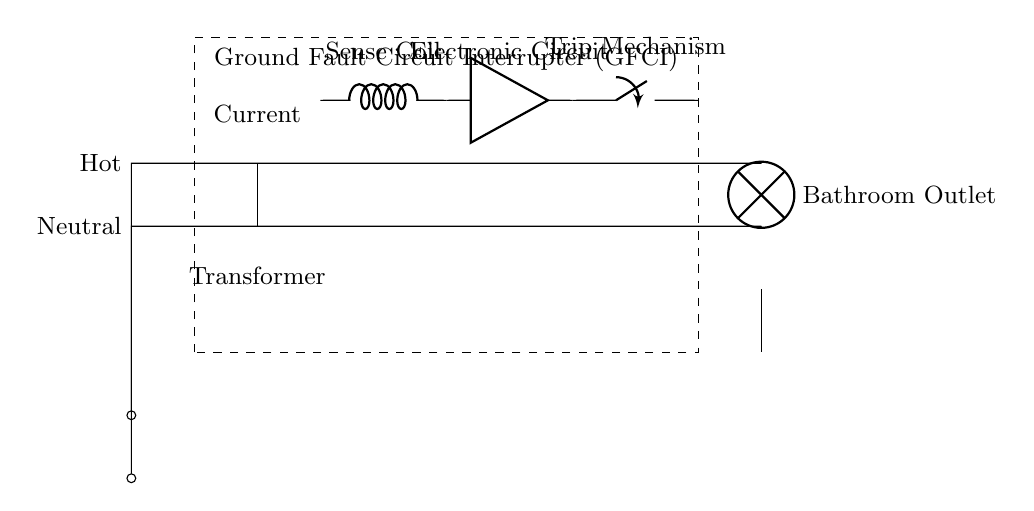What is the main function of the GFCI? The main function of the GFCI is to detect ground faults and prevent electric shock by interrupting the circuit.
Answer: Detect ground faults What type of load is connected to the circuit? The load connected to the circuit is a lamp, indicated by the symbol in the diagram.
Answer: Lamp How many components are inside the GFCI? The GFCI contains four main components: a current transformer, a sense coil, an electronic circuit, and a trip mechanism.
Answer: Four What is the purpose of the sense coil? The purpose of the sense coil is to detect the current imbalance caused by a ground fault, which helps in tripping the circuit.
Answer: Detect current imbalance What happens when a ground fault is detected? When a ground fault is detected, the trip mechanism activates to open the circuit, stopping the flow of electricity to prevent shock.
Answer: Circuit opens What do the labels "Hot" and "Neutral" indicate? The labels identify the two main power lines in the circuit: "Hot" carries current, while "Neutral" completes the circuit back to the power source.
Answer: Power lines What does the ground symbol represent? The ground symbol indicates the safety ground connection, which provides a path for excess electricity to safely dissipate into the earth.
Answer: Safety ground 